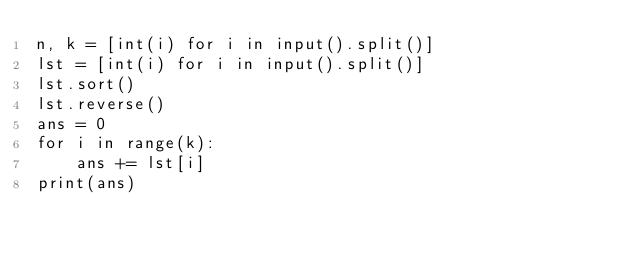<code> <loc_0><loc_0><loc_500><loc_500><_Python_>n, k = [int(i) for i in input().split()]
lst = [int(i) for i in input().split()]
lst.sort()
lst.reverse()
ans = 0
for i in range(k):
    ans += lst[i]
print(ans)</code> 